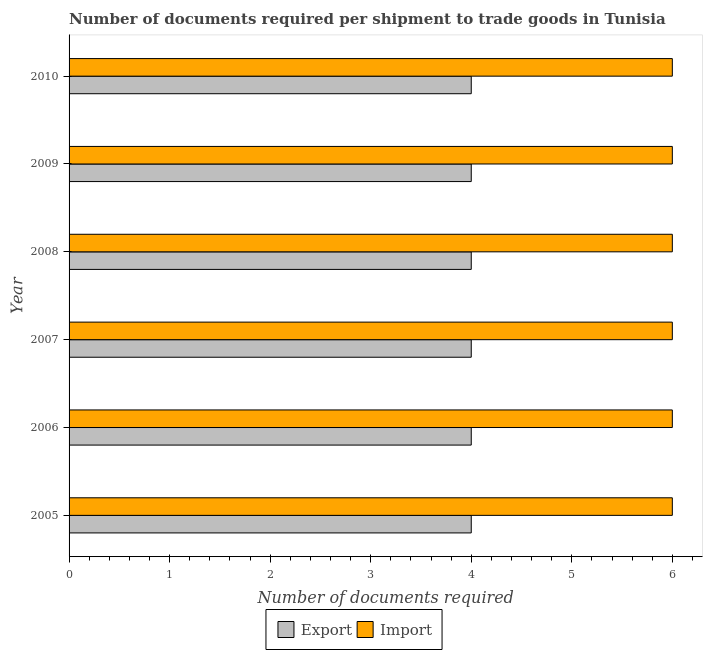How many different coloured bars are there?
Offer a very short reply. 2. Are the number of bars on each tick of the Y-axis equal?
Ensure brevity in your answer.  Yes. How many bars are there on the 2nd tick from the bottom?
Your answer should be compact. 2. What is the number of documents required to import goods in 2007?
Your response must be concise. 6. Across all years, what is the maximum number of documents required to import goods?
Make the answer very short. 6. Across all years, what is the minimum number of documents required to export goods?
Make the answer very short. 4. In which year was the number of documents required to export goods maximum?
Ensure brevity in your answer.  2005. In which year was the number of documents required to import goods minimum?
Make the answer very short. 2005. What is the total number of documents required to import goods in the graph?
Offer a very short reply. 36. What is the difference between the number of documents required to export goods in 2005 and that in 2009?
Make the answer very short. 0. What is the difference between the number of documents required to import goods in 2008 and the number of documents required to export goods in 2010?
Your answer should be compact. 2. In the year 2007, what is the difference between the number of documents required to import goods and number of documents required to export goods?
Your response must be concise. 2. In how many years, is the number of documents required to export goods greater than 0.2 ?
Give a very brief answer. 6. Is the difference between the number of documents required to import goods in 2005 and 2007 greater than the difference between the number of documents required to export goods in 2005 and 2007?
Offer a very short reply. No. What is the difference between the highest and the second highest number of documents required to export goods?
Provide a short and direct response. 0. What is the difference between the highest and the lowest number of documents required to export goods?
Offer a terse response. 0. Is the sum of the number of documents required to import goods in 2005 and 2010 greater than the maximum number of documents required to export goods across all years?
Give a very brief answer. Yes. What does the 1st bar from the top in 2005 represents?
Make the answer very short. Import. What does the 1st bar from the bottom in 2009 represents?
Your answer should be compact. Export. How many bars are there?
Provide a succinct answer. 12. Are all the bars in the graph horizontal?
Your response must be concise. Yes. How many years are there in the graph?
Your answer should be compact. 6. What is the difference between two consecutive major ticks on the X-axis?
Offer a terse response. 1. Does the graph contain any zero values?
Provide a succinct answer. No. What is the title of the graph?
Provide a succinct answer. Number of documents required per shipment to trade goods in Tunisia. Does "Not attending school" appear as one of the legend labels in the graph?
Keep it short and to the point. No. What is the label or title of the X-axis?
Ensure brevity in your answer.  Number of documents required. What is the label or title of the Y-axis?
Offer a terse response. Year. What is the Number of documents required of Import in 2005?
Provide a succinct answer. 6. What is the Number of documents required in Export in 2006?
Keep it short and to the point. 4. What is the Number of documents required in Import in 2006?
Ensure brevity in your answer.  6. What is the Number of documents required in Import in 2007?
Your response must be concise. 6. What is the Number of documents required in Export in 2008?
Keep it short and to the point. 4. What is the Number of documents required of Import in 2008?
Keep it short and to the point. 6. What is the Number of documents required of Export in 2010?
Provide a short and direct response. 4. What is the Number of documents required of Import in 2010?
Provide a short and direct response. 6. Across all years, what is the maximum Number of documents required of Import?
Ensure brevity in your answer.  6. Across all years, what is the minimum Number of documents required of Export?
Offer a terse response. 4. What is the total Number of documents required of Import in the graph?
Offer a very short reply. 36. What is the difference between the Number of documents required of Import in 2005 and that in 2006?
Make the answer very short. 0. What is the difference between the Number of documents required in Import in 2005 and that in 2008?
Your response must be concise. 0. What is the difference between the Number of documents required of Export in 2005 and that in 2009?
Keep it short and to the point. 0. What is the difference between the Number of documents required in Export in 2005 and that in 2010?
Make the answer very short. 0. What is the difference between the Number of documents required in Export in 2006 and that in 2007?
Your answer should be very brief. 0. What is the difference between the Number of documents required of Import in 2006 and that in 2009?
Ensure brevity in your answer.  0. What is the difference between the Number of documents required of Export in 2007 and that in 2008?
Give a very brief answer. 0. What is the difference between the Number of documents required in Export in 2007 and that in 2009?
Make the answer very short. 0. What is the difference between the Number of documents required of Import in 2007 and that in 2009?
Provide a short and direct response. 0. What is the difference between the Number of documents required in Export in 2007 and that in 2010?
Ensure brevity in your answer.  0. What is the difference between the Number of documents required in Import in 2008 and that in 2009?
Make the answer very short. 0. What is the difference between the Number of documents required of Export in 2008 and that in 2010?
Give a very brief answer. 0. What is the difference between the Number of documents required of Import in 2009 and that in 2010?
Offer a very short reply. 0. What is the difference between the Number of documents required of Export in 2005 and the Number of documents required of Import in 2006?
Provide a short and direct response. -2. What is the difference between the Number of documents required of Export in 2005 and the Number of documents required of Import in 2007?
Provide a short and direct response. -2. What is the difference between the Number of documents required in Export in 2005 and the Number of documents required in Import in 2009?
Keep it short and to the point. -2. What is the difference between the Number of documents required of Export in 2006 and the Number of documents required of Import in 2007?
Give a very brief answer. -2. What is the difference between the Number of documents required in Export in 2006 and the Number of documents required in Import in 2008?
Offer a very short reply. -2. What is the difference between the Number of documents required in Export in 2006 and the Number of documents required in Import in 2010?
Keep it short and to the point. -2. What is the difference between the Number of documents required in Export in 2007 and the Number of documents required in Import in 2008?
Ensure brevity in your answer.  -2. What is the difference between the Number of documents required in Export in 2007 and the Number of documents required in Import in 2009?
Provide a short and direct response. -2. What is the difference between the Number of documents required in Export in 2007 and the Number of documents required in Import in 2010?
Make the answer very short. -2. What is the difference between the Number of documents required of Export in 2008 and the Number of documents required of Import in 2009?
Your response must be concise. -2. What is the difference between the Number of documents required of Export in 2009 and the Number of documents required of Import in 2010?
Make the answer very short. -2. What is the average Number of documents required in Export per year?
Make the answer very short. 4. In the year 2005, what is the difference between the Number of documents required of Export and Number of documents required of Import?
Make the answer very short. -2. In the year 2010, what is the difference between the Number of documents required of Export and Number of documents required of Import?
Make the answer very short. -2. What is the ratio of the Number of documents required in Export in 2005 to that in 2006?
Give a very brief answer. 1. What is the ratio of the Number of documents required of Import in 2005 to that in 2006?
Give a very brief answer. 1. What is the ratio of the Number of documents required in Import in 2005 to that in 2007?
Your answer should be compact. 1. What is the ratio of the Number of documents required in Import in 2005 to that in 2008?
Provide a succinct answer. 1. What is the ratio of the Number of documents required in Import in 2005 to that in 2009?
Offer a terse response. 1. What is the ratio of the Number of documents required of Import in 2005 to that in 2010?
Make the answer very short. 1. What is the ratio of the Number of documents required of Export in 2006 to that in 2007?
Keep it short and to the point. 1. What is the ratio of the Number of documents required in Import in 2006 to that in 2007?
Make the answer very short. 1. What is the ratio of the Number of documents required in Export in 2006 to that in 2010?
Give a very brief answer. 1. What is the ratio of the Number of documents required in Import in 2006 to that in 2010?
Offer a very short reply. 1. What is the ratio of the Number of documents required in Import in 2007 to that in 2008?
Your response must be concise. 1. What is the ratio of the Number of documents required of Import in 2007 to that in 2009?
Your answer should be very brief. 1. What is the ratio of the Number of documents required of Import in 2007 to that in 2010?
Your answer should be compact. 1. What is the ratio of the Number of documents required of Import in 2008 to that in 2010?
Your answer should be compact. 1. What is the ratio of the Number of documents required of Export in 2009 to that in 2010?
Provide a succinct answer. 1. What is the difference between the highest and the second highest Number of documents required in Export?
Your answer should be very brief. 0. What is the difference between the highest and the second highest Number of documents required of Import?
Provide a succinct answer. 0. What is the difference between the highest and the lowest Number of documents required in Export?
Give a very brief answer. 0. 